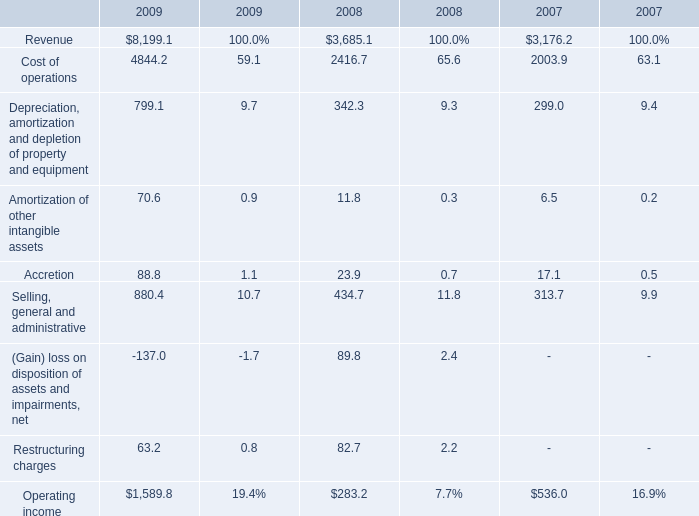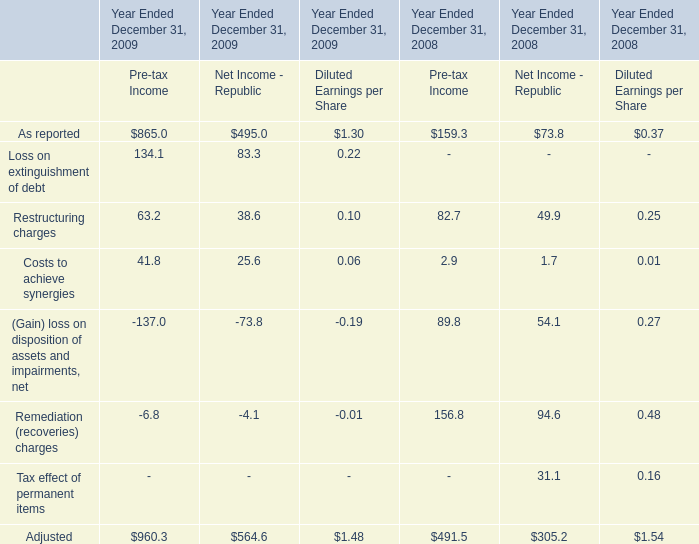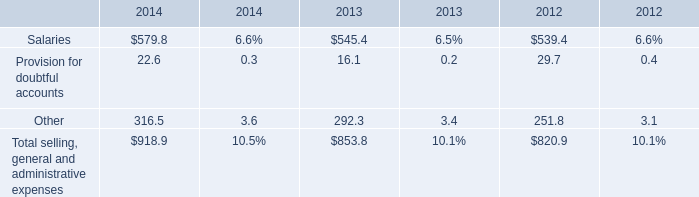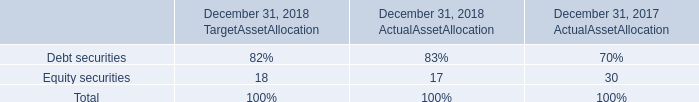What's the growth rate of Cost of operations in 2009? 
Computations: ((4844.2 - 2416.7) / 2416.7)
Answer: 1.00447. 